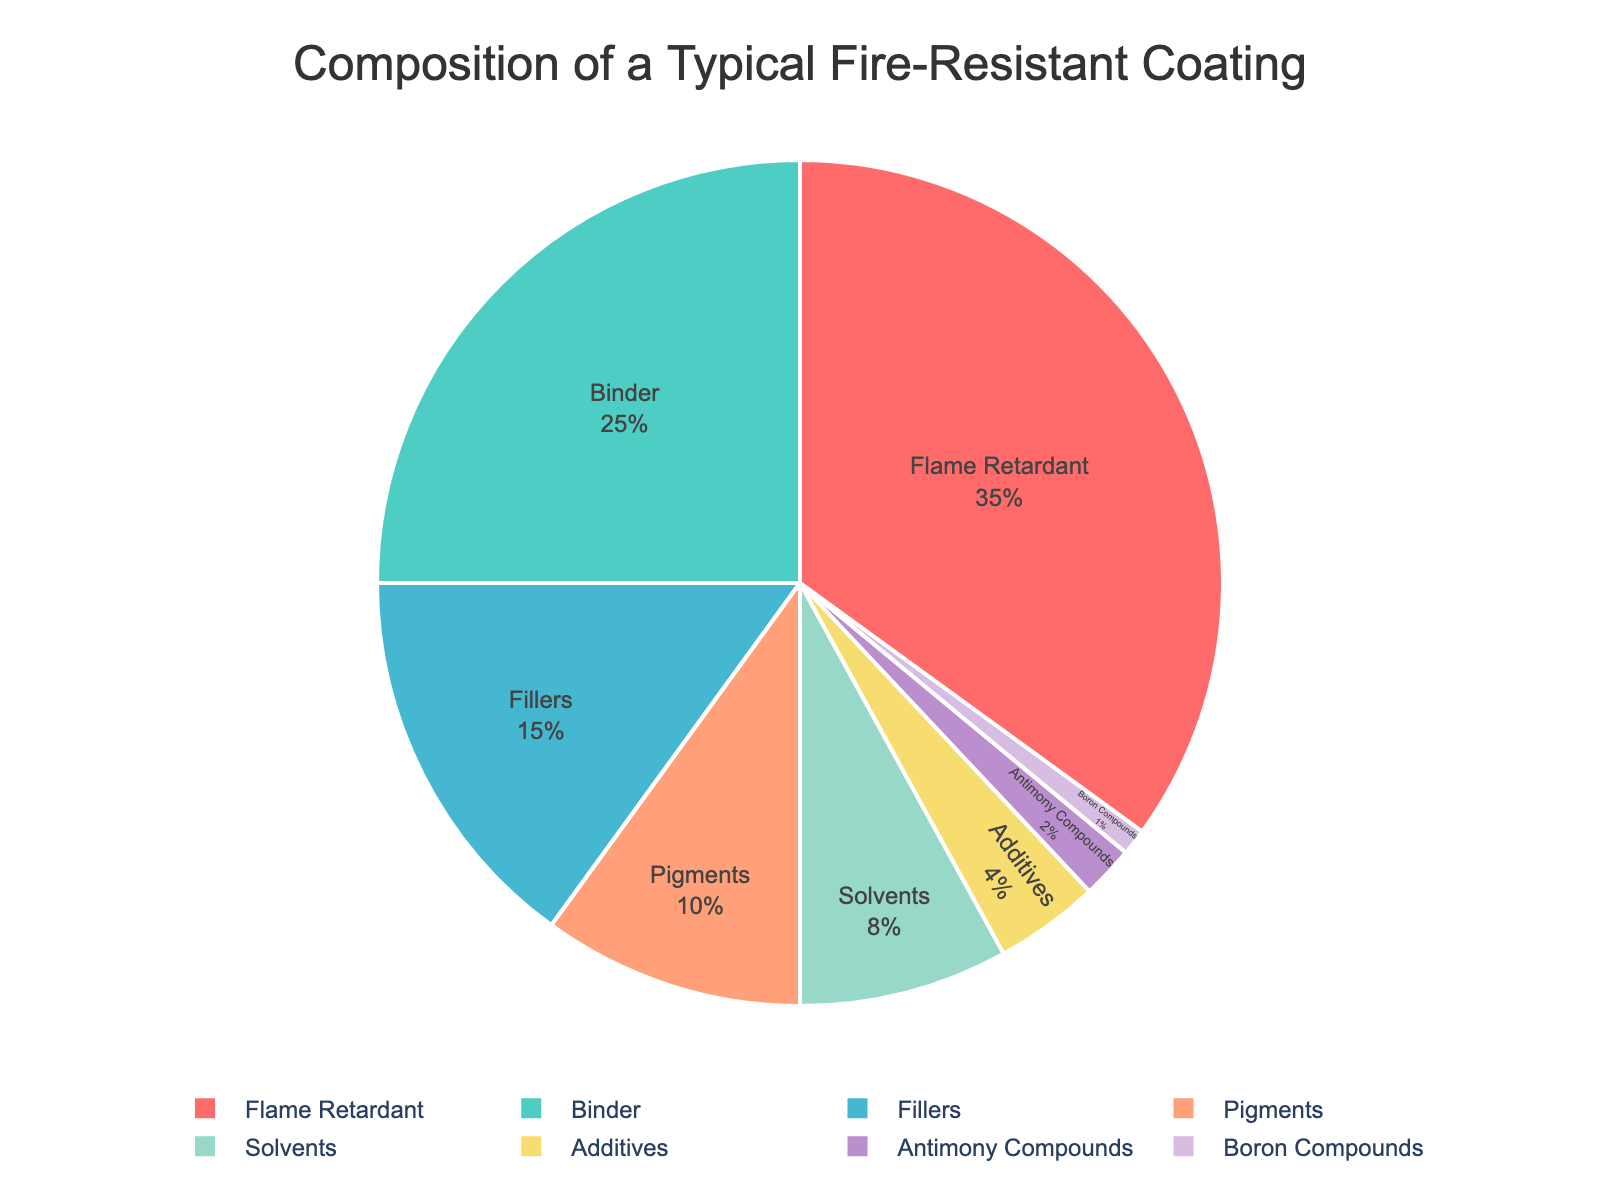Which ingredient makes up the largest portion of the fire-resistant coating? The figure shows the percentages of various ingredients, and the largest segment corresponds to flame retardant, which is 35%.
Answer: Flame Retardant What is the combined percentage of binders and fillers? According to the figure, binders make up 25% and fillers make up 15%. Adding these together gives 25% + 15% = 40%.
Answer: 40% How much more percentage does flame retardant have compared to pigments? Flame retardant is 35% and pigments are 10%. The difference is 35% - 10% = 25%.
Answer: 25% Which ingredient has the smallest percentage, and what is it? The smallest segment in the pie chart corresponds to boron compounds, which make up 1%.
Answer: Boron Compounds, 1% How do the percentages of solvents and additives compare? Solvents make up 8% and additives make up 4%, so solvents have double the percentage of additives.
Answer: Solvents have double What percentage do all the ingredients together make up, excluding solvents and additives? Adding the percentages of all ingredients except solvents (8%) and additives (4%): 35% + 25% + 15% + 10% + 2% + 1% = 88%.
Answer: 88% Are binders more or less prevalent than fillers and pigments combined? Fillers are 15% and pigments are 10%, summing to 15% + 10% = 25%, which is equal to the percentage of binders (also 25%).
Answer: Equal What is the total percentage of all the minor ingredients (those less than or equal to 4%)? The minor ingredients are additives (4%), antimony compounds (2%), and boron compounds (1%). Adding these, 4% + 2% + 1% = 7%.
Answer: 7% 